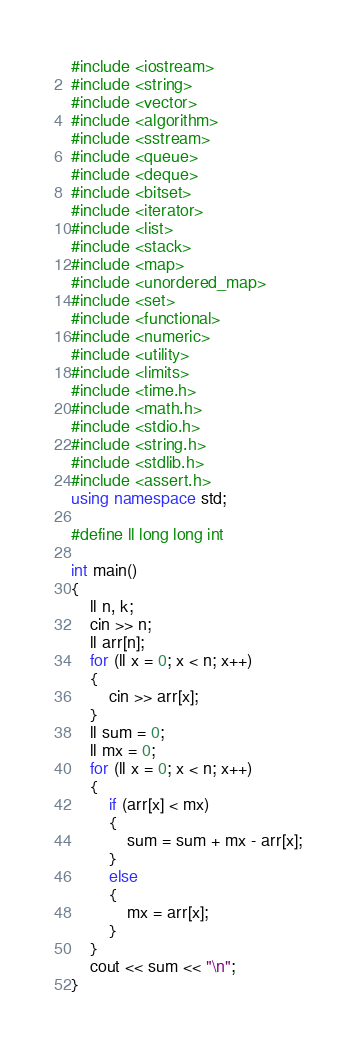<code> <loc_0><loc_0><loc_500><loc_500><_C++_>#include <iostream>
#include <string>
#include <vector>
#include <algorithm>
#include <sstream>
#include <queue>
#include <deque>
#include <bitset>
#include <iterator>
#include <list>
#include <stack>
#include <map>
#include <unordered_map>
#include <set>
#include <functional>
#include <numeric>
#include <utility>
#include <limits>
#include <time.h>
#include <math.h>
#include <stdio.h>
#include <string.h>
#include <stdlib.h>
#include <assert.h>
using namespace std;

#define ll long long int

int main()
{
    ll n, k;
    cin >> n;
    ll arr[n];
    for (ll x = 0; x < n; x++)
    {
        cin >> arr[x];
    }
    ll sum = 0;
    ll mx = 0;
    for (ll x = 0; x < n; x++)
    {
        if (arr[x] < mx)
        {
            sum = sum + mx - arr[x];
        }
        else
        {
            mx = arr[x];
        }
    }
    cout << sum << "\n";
}</code> 